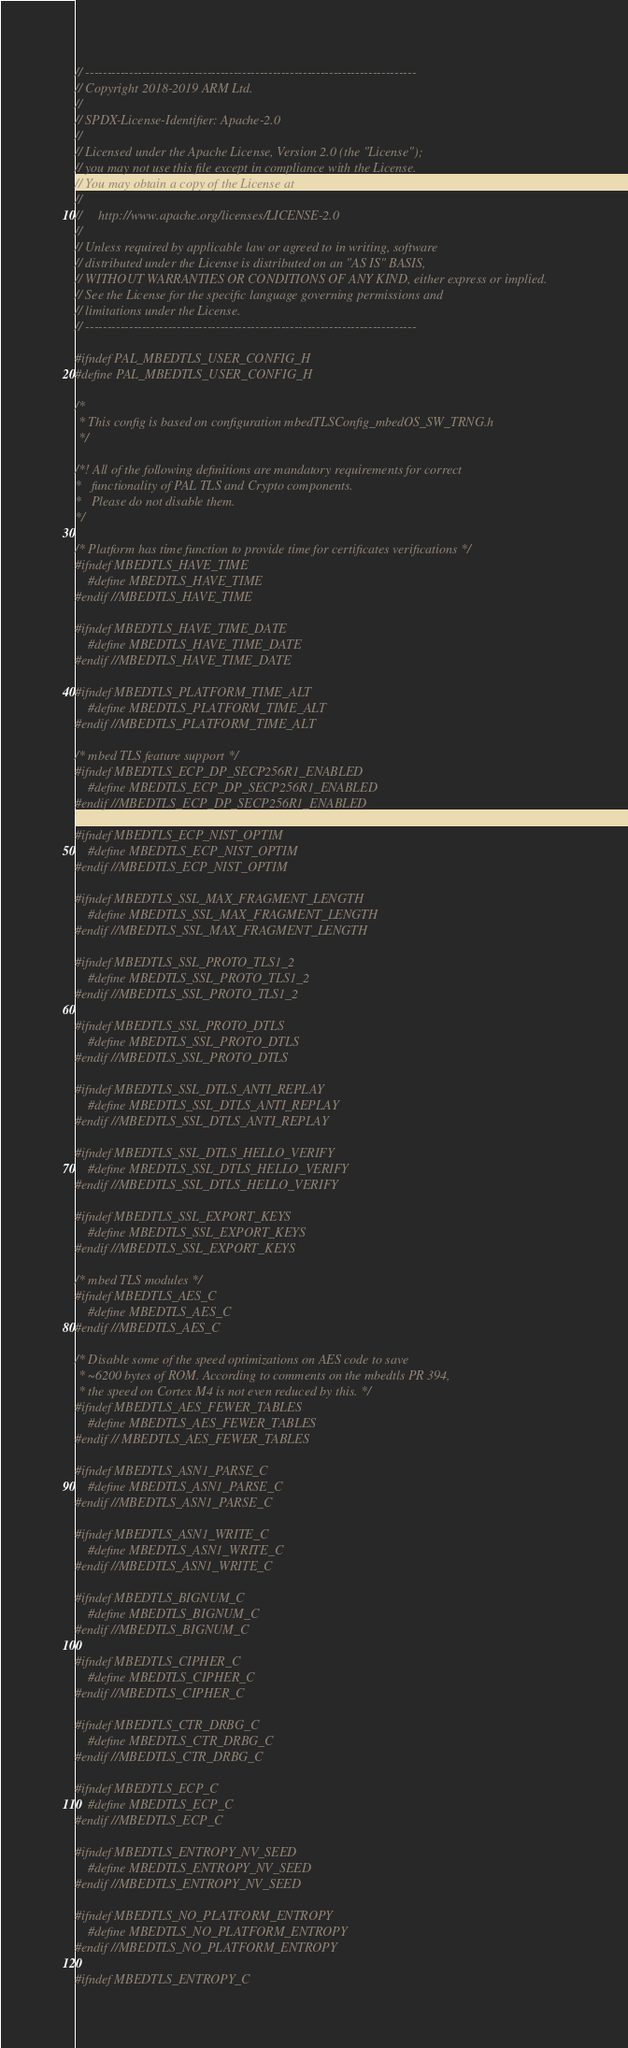<code> <loc_0><loc_0><loc_500><loc_500><_C_>// ----------------------------------------------------------------------------
// Copyright 2018-2019 ARM Ltd.
//
// SPDX-License-Identifier: Apache-2.0
//
// Licensed under the Apache License, Version 2.0 (the "License");
// you may not use this file except in compliance with the License.
// You may obtain a copy of the License at
//
//     http://www.apache.org/licenses/LICENSE-2.0
//
// Unless required by applicable law or agreed to in writing, software
// distributed under the License is distributed on an "AS IS" BASIS,
// WITHOUT WARRANTIES OR CONDITIONS OF ANY KIND, either express or implied.
// See the License for the specific language governing permissions and
// limitations under the License.
// ----------------------------------------------------------------------------

#ifndef PAL_MBEDTLS_USER_CONFIG_H
#define PAL_MBEDTLS_USER_CONFIG_H

/*
 * This config is based on configuration mbedTLSConfig_mbedOS_SW_TRNG.h
 */

/*! All of the following definitions are mandatory requirements for correct
*   functionality of PAL TLS and Crypto components.
*   Please do not disable them.
*/

/* Platform has time function to provide time for certificates verifications */
#ifndef MBEDTLS_HAVE_TIME
    #define MBEDTLS_HAVE_TIME
#endif //MBEDTLS_HAVE_TIME

#ifndef MBEDTLS_HAVE_TIME_DATE
    #define MBEDTLS_HAVE_TIME_DATE
#endif //MBEDTLS_HAVE_TIME_DATE

#ifndef MBEDTLS_PLATFORM_TIME_ALT
    #define MBEDTLS_PLATFORM_TIME_ALT
#endif //MBEDTLS_PLATFORM_TIME_ALT

/* mbed TLS feature support */
#ifndef MBEDTLS_ECP_DP_SECP256R1_ENABLED
    #define MBEDTLS_ECP_DP_SECP256R1_ENABLED
#endif //MBEDTLS_ECP_DP_SECP256R1_ENABLED

#ifndef MBEDTLS_ECP_NIST_OPTIM
    #define MBEDTLS_ECP_NIST_OPTIM
#endif //MBEDTLS_ECP_NIST_OPTIM

#ifndef MBEDTLS_SSL_MAX_FRAGMENT_LENGTH
    #define MBEDTLS_SSL_MAX_FRAGMENT_LENGTH
#endif //MBEDTLS_SSL_MAX_FRAGMENT_LENGTH

#ifndef MBEDTLS_SSL_PROTO_TLS1_2
    #define MBEDTLS_SSL_PROTO_TLS1_2
#endif //MBEDTLS_SSL_PROTO_TLS1_2

#ifndef MBEDTLS_SSL_PROTO_DTLS
    #define MBEDTLS_SSL_PROTO_DTLS
#endif //MBEDTLS_SSL_PROTO_DTLS

#ifndef MBEDTLS_SSL_DTLS_ANTI_REPLAY
    #define MBEDTLS_SSL_DTLS_ANTI_REPLAY
#endif //MBEDTLS_SSL_DTLS_ANTI_REPLAY

#ifndef MBEDTLS_SSL_DTLS_HELLO_VERIFY
    #define MBEDTLS_SSL_DTLS_HELLO_VERIFY
#endif //MBEDTLS_SSL_DTLS_HELLO_VERIFY

#ifndef MBEDTLS_SSL_EXPORT_KEYS
    #define MBEDTLS_SSL_EXPORT_KEYS
#endif //MBEDTLS_SSL_EXPORT_KEYS

/* mbed TLS modules */
#ifndef MBEDTLS_AES_C
    #define MBEDTLS_AES_C
#endif //MBEDTLS_AES_C

/* Disable some of the speed optimizations on AES code to save
 * ~6200 bytes of ROM. According to comments on the mbedtls PR 394,
 * the speed on Cortex M4 is not even reduced by this. */
#ifndef MBEDTLS_AES_FEWER_TABLES
    #define MBEDTLS_AES_FEWER_TABLES
#endif // MBEDTLS_AES_FEWER_TABLES

#ifndef MBEDTLS_ASN1_PARSE_C
    #define MBEDTLS_ASN1_PARSE_C
#endif //MBEDTLS_ASN1_PARSE_C

#ifndef MBEDTLS_ASN1_WRITE_C
    #define MBEDTLS_ASN1_WRITE_C
#endif //MBEDTLS_ASN1_WRITE_C

#ifndef MBEDTLS_BIGNUM_C
    #define MBEDTLS_BIGNUM_C
#endif //MBEDTLS_BIGNUM_C

#ifndef MBEDTLS_CIPHER_C
    #define MBEDTLS_CIPHER_C
#endif //MBEDTLS_CIPHER_C

#ifndef MBEDTLS_CTR_DRBG_C
    #define MBEDTLS_CTR_DRBG_C
#endif //MBEDTLS_CTR_DRBG_C

#ifndef MBEDTLS_ECP_C
    #define MBEDTLS_ECP_C
#endif //MBEDTLS_ECP_C

#ifndef MBEDTLS_ENTROPY_NV_SEED
    #define MBEDTLS_ENTROPY_NV_SEED
#endif //MBEDTLS_ENTROPY_NV_SEED

#ifndef MBEDTLS_NO_PLATFORM_ENTROPY
    #define MBEDTLS_NO_PLATFORM_ENTROPY
#endif //MBEDTLS_NO_PLATFORM_ENTROPY

#ifndef MBEDTLS_ENTROPY_C</code> 